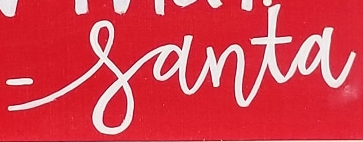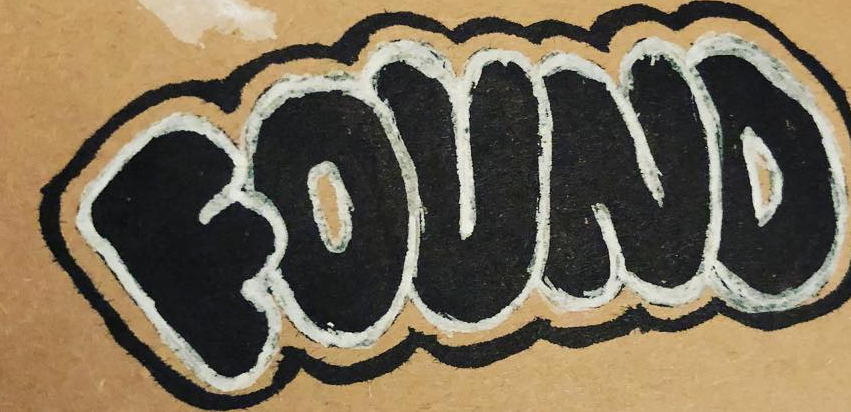Transcribe the words shown in these images in order, separated by a semicolon. -santa; FOUND 